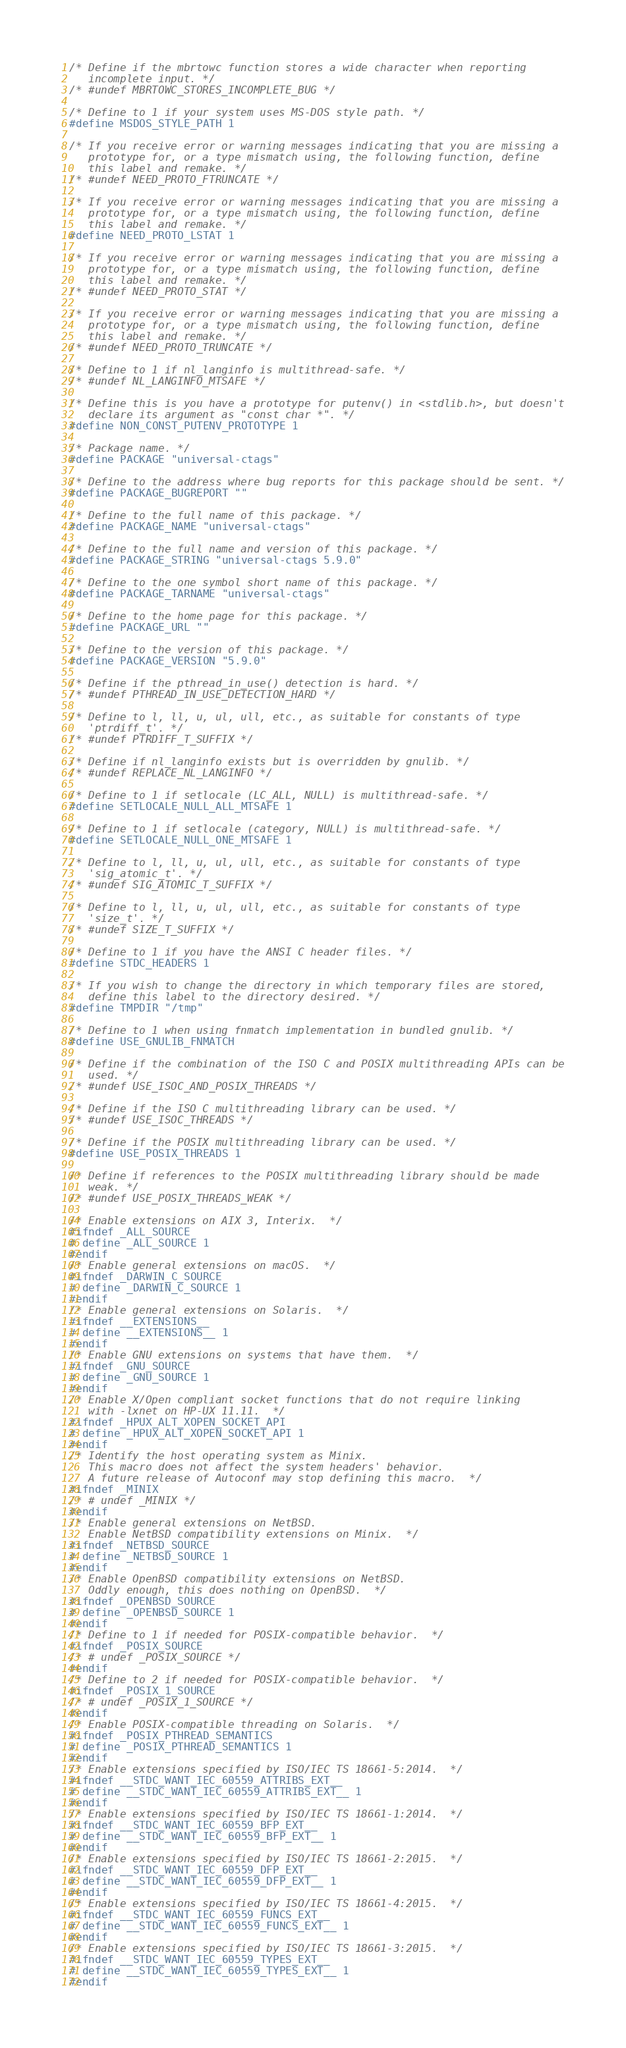Convert code to text. <code><loc_0><loc_0><loc_500><loc_500><_C_>
/* Define if the mbrtowc function stores a wide character when reporting
   incomplete input. */
/* #undef MBRTOWC_STORES_INCOMPLETE_BUG */

/* Define to 1 if your system uses MS-DOS style path. */
#define MSDOS_STYLE_PATH 1

/* If you receive error or warning messages indicating that you are missing a
   prototype for, or a type mismatch using, the following function, define
   this label and remake. */
/* #undef NEED_PROTO_FTRUNCATE */

/* If you receive error or warning messages indicating that you are missing a
   prototype for, or a type mismatch using, the following function, define
   this label and remake. */
#define NEED_PROTO_LSTAT 1

/* If you receive error or warning messages indicating that you are missing a
   prototype for, or a type mismatch using, the following function, define
   this label and remake. */
/* #undef NEED_PROTO_STAT */

/* If you receive error or warning messages indicating that you are missing a
   prototype for, or a type mismatch using, the following function, define
   this label and remake. */
/* #undef NEED_PROTO_TRUNCATE */

/* Define to 1 if nl_langinfo is multithread-safe. */
/* #undef NL_LANGINFO_MTSAFE */

/* Define this is you have a prototype for putenv() in <stdlib.h>, but doesn't
   declare its argument as "const char *". */
#define NON_CONST_PUTENV_PROTOTYPE 1

/* Package name. */
#define PACKAGE "universal-ctags"

/* Define to the address where bug reports for this package should be sent. */
#define PACKAGE_BUGREPORT ""

/* Define to the full name of this package. */
#define PACKAGE_NAME "universal-ctags"

/* Define to the full name and version of this package. */
#define PACKAGE_STRING "universal-ctags 5.9.0"

/* Define to the one symbol short name of this package. */
#define PACKAGE_TARNAME "universal-ctags"

/* Define to the home page for this package. */
#define PACKAGE_URL ""

/* Define to the version of this package. */
#define PACKAGE_VERSION "5.9.0"

/* Define if the pthread_in_use() detection is hard. */
/* #undef PTHREAD_IN_USE_DETECTION_HARD */

/* Define to l, ll, u, ul, ull, etc., as suitable for constants of type
   'ptrdiff_t'. */
/* #undef PTRDIFF_T_SUFFIX */

/* Define if nl_langinfo exists but is overridden by gnulib. */
/* #undef REPLACE_NL_LANGINFO */

/* Define to 1 if setlocale (LC_ALL, NULL) is multithread-safe. */
#define SETLOCALE_NULL_ALL_MTSAFE 1

/* Define to 1 if setlocale (category, NULL) is multithread-safe. */
#define SETLOCALE_NULL_ONE_MTSAFE 1

/* Define to l, ll, u, ul, ull, etc., as suitable for constants of type
   'sig_atomic_t'. */
/* #undef SIG_ATOMIC_T_SUFFIX */

/* Define to l, ll, u, ul, ull, etc., as suitable for constants of type
   'size_t'. */
/* #undef SIZE_T_SUFFIX */

/* Define to 1 if you have the ANSI C header files. */
#define STDC_HEADERS 1

/* If you wish to change the directory in which temporary files are stored,
   define this label to the directory desired. */
#define TMPDIR "/tmp"

/* Define to 1 when using fnmatch implementation in bundled gnulib. */
#define USE_GNULIB_FNMATCH

/* Define if the combination of the ISO C and POSIX multithreading APIs can be
   used. */
/* #undef USE_ISOC_AND_POSIX_THREADS */

/* Define if the ISO C multithreading library can be used. */
/* #undef USE_ISOC_THREADS */

/* Define if the POSIX multithreading library can be used. */
#define USE_POSIX_THREADS 1

/* Define if references to the POSIX multithreading library should be made
   weak. */
/* #undef USE_POSIX_THREADS_WEAK */

/* Enable extensions on AIX 3, Interix.  */
#ifndef _ALL_SOURCE
# define _ALL_SOURCE 1
#endif
/* Enable general extensions on macOS.  */
#ifndef _DARWIN_C_SOURCE
# define _DARWIN_C_SOURCE 1
#endif
/* Enable general extensions on Solaris.  */
#ifndef __EXTENSIONS__
# define __EXTENSIONS__ 1
#endif
/* Enable GNU extensions on systems that have them.  */
#ifndef _GNU_SOURCE
# define _GNU_SOURCE 1
#endif
/* Enable X/Open compliant socket functions that do not require linking
   with -lxnet on HP-UX 11.11.  */
#ifndef _HPUX_ALT_XOPEN_SOCKET_API
# define _HPUX_ALT_XOPEN_SOCKET_API 1
#endif
/* Identify the host operating system as Minix.
   This macro does not affect the system headers' behavior.
   A future release of Autoconf may stop defining this macro.  */
#ifndef _MINIX
/* # undef _MINIX */
#endif
/* Enable general extensions on NetBSD.
   Enable NetBSD compatibility extensions on Minix.  */
#ifndef _NETBSD_SOURCE
# define _NETBSD_SOURCE 1
#endif
/* Enable OpenBSD compatibility extensions on NetBSD.
   Oddly enough, this does nothing on OpenBSD.  */
#ifndef _OPENBSD_SOURCE
# define _OPENBSD_SOURCE 1
#endif
/* Define to 1 if needed for POSIX-compatible behavior.  */
#ifndef _POSIX_SOURCE
/* # undef _POSIX_SOURCE */
#endif
/* Define to 2 if needed for POSIX-compatible behavior.  */
#ifndef _POSIX_1_SOURCE
/* # undef _POSIX_1_SOURCE */
#endif
/* Enable POSIX-compatible threading on Solaris.  */
#ifndef _POSIX_PTHREAD_SEMANTICS
# define _POSIX_PTHREAD_SEMANTICS 1
#endif
/* Enable extensions specified by ISO/IEC TS 18661-5:2014.  */
#ifndef __STDC_WANT_IEC_60559_ATTRIBS_EXT__
# define __STDC_WANT_IEC_60559_ATTRIBS_EXT__ 1
#endif
/* Enable extensions specified by ISO/IEC TS 18661-1:2014.  */
#ifndef __STDC_WANT_IEC_60559_BFP_EXT__
# define __STDC_WANT_IEC_60559_BFP_EXT__ 1
#endif
/* Enable extensions specified by ISO/IEC TS 18661-2:2015.  */
#ifndef __STDC_WANT_IEC_60559_DFP_EXT__
# define __STDC_WANT_IEC_60559_DFP_EXT__ 1
#endif
/* Enable extensions specified by ISO/IEC TS 18661-4:2015.  */
#ifndef __STDC_WANT_IEC_60559_FUNCS_EXT__
# define __STDC_WANT_IEC_60559_FUNCS_EXT__ 1
#endif
/* Enable extensions specified by ISO/IEC TS 18661-3:2015.  */
#ifndef __STDC_WANT_IEC_60559_TYPES_EXT__
# define __STDC_WANT_IEC_60559_TYPES_EXT__ 1
#endif</code> 